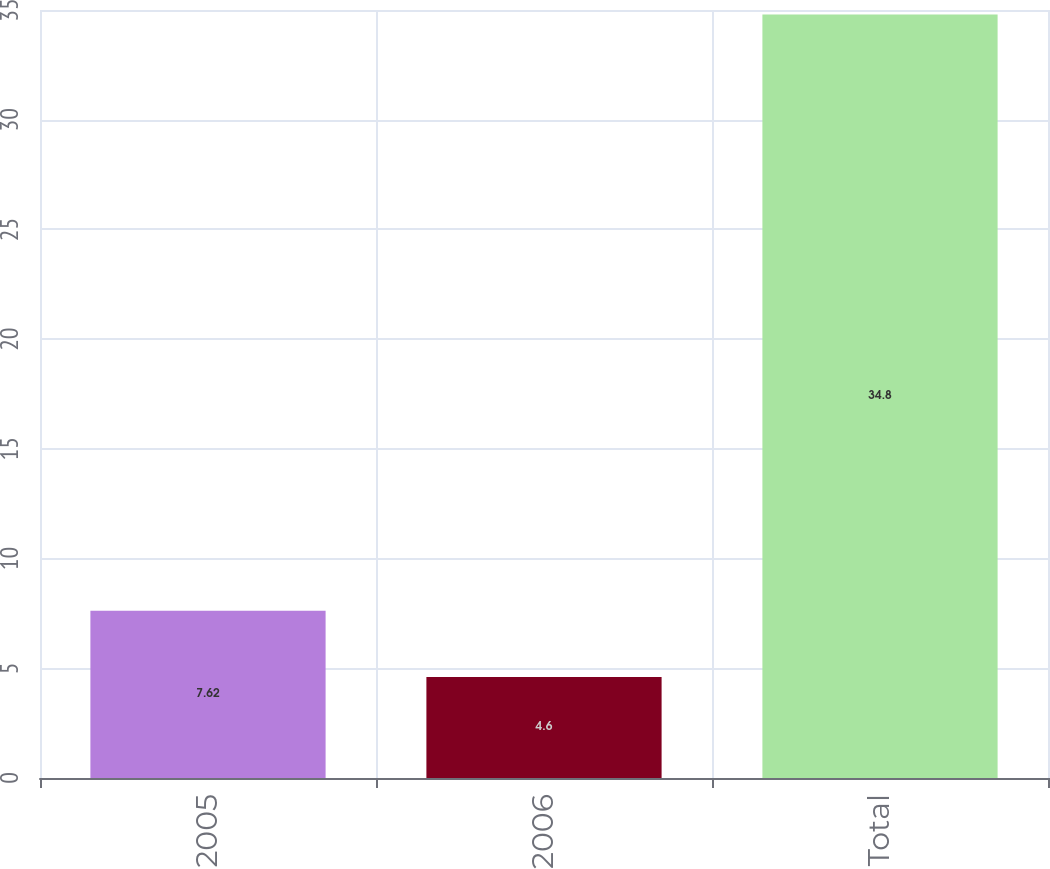Convert chart. <chart><loc_0><loc_0><loc_500><loc_500><bar_chart><fcel>2005<fcel>2006<fcel>Total<nl><fcel>7.62<fcel>4.6<fcel>34.8<nl></chart> 